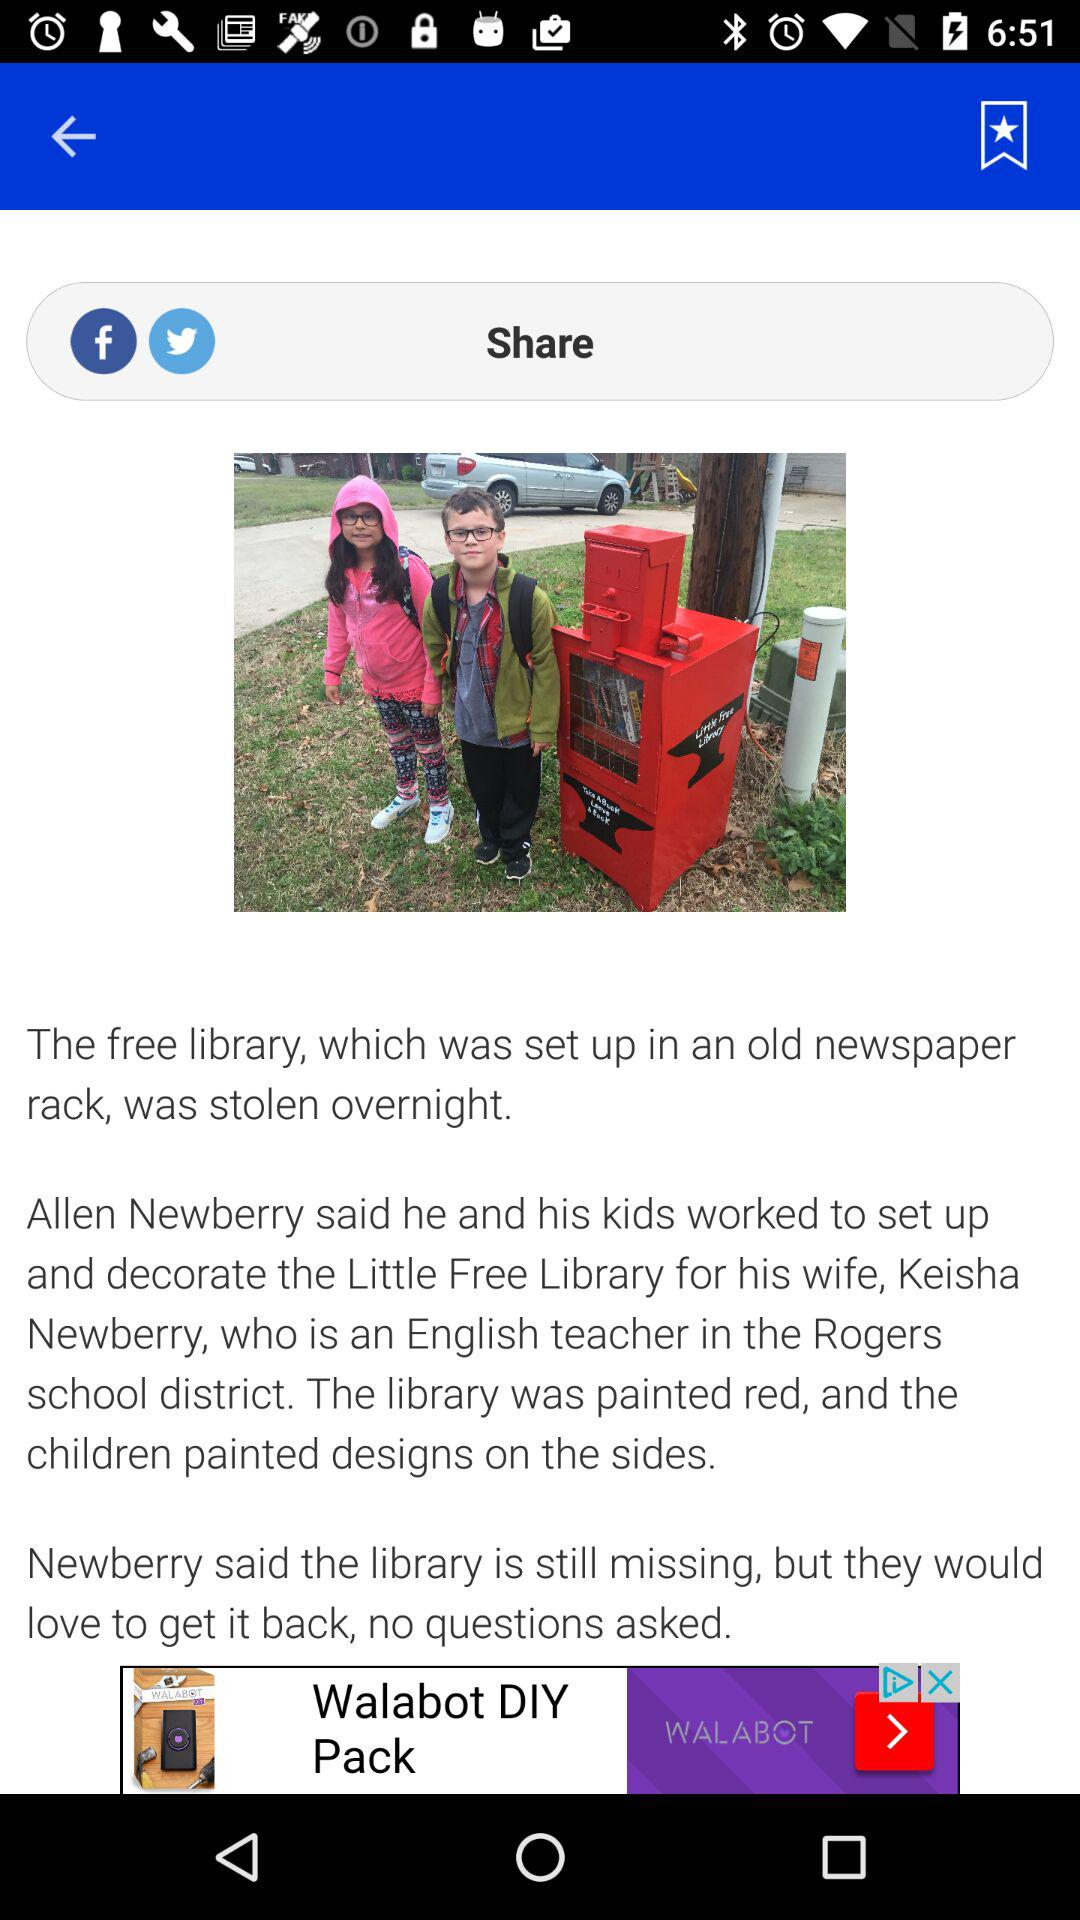Through which application can it be shared? It can be shared through "Facebook" and "Twitter". 